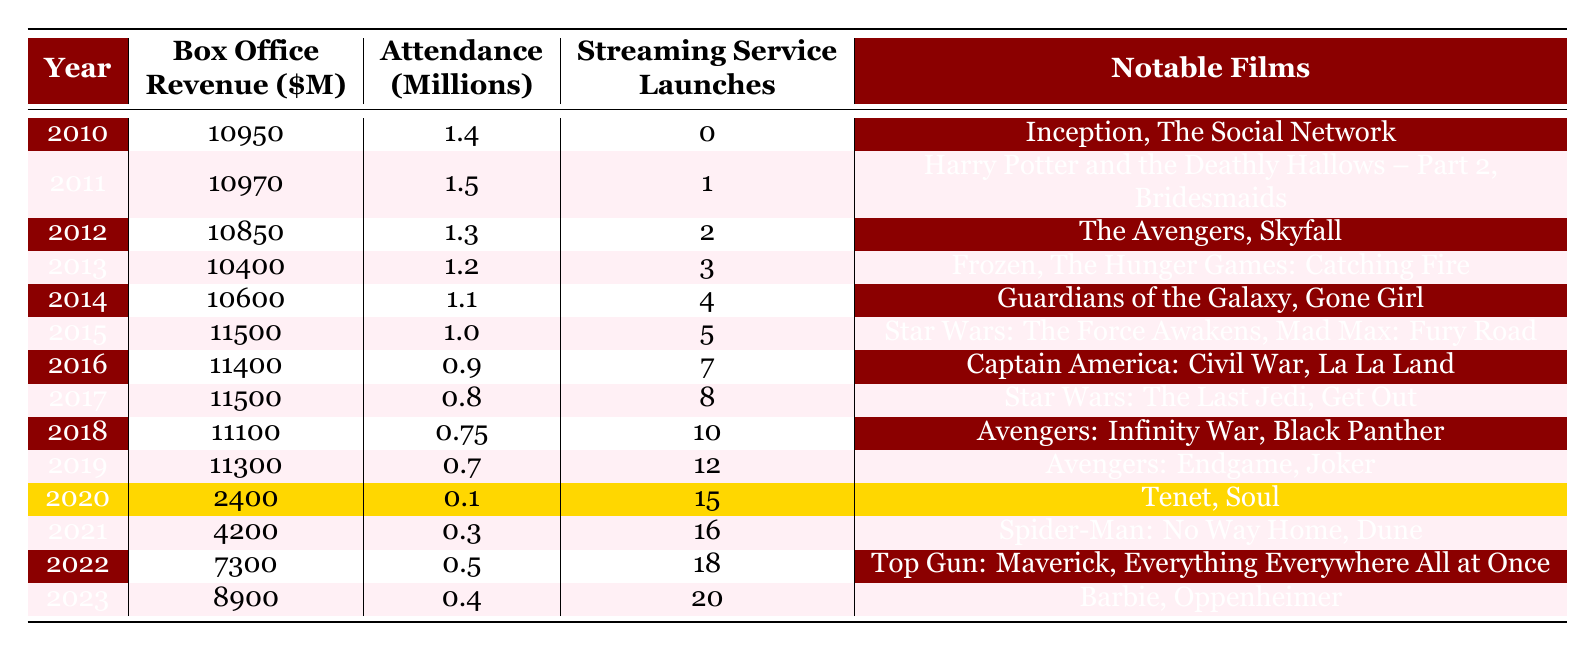What was the box office revenue in 2015? In the row for 2015, the box office revenue value is given as 11,500 million dollars.
Answer: 11500 How many streaming services launched in 2020? The table indicates that there were 15 streaming service launches in 2020.
Answer: 15 In which year did theater attendance first drop below 1 million? The attendance values show that in 2016, attendance was 0.9 million, thus it dropped below 1 million for the first time.
Answer: 2016 What was the box office revenue trend from 2010 to 2019? By comparing the box office revenues year by year from 2010 to 2019, it initially rose slightly before experiencing fluctuations, but generally maintained values around 10,000 million until 2019, where it was recorded at 11,300 million.
Answer: Fluctuating, stable around 10,000 million until 2019 What is the average attendance from 2013 to 2015? The attendance figures for 2013, 2014, and 2015 are 1.2, 1.1, and 1.0 million, respectively. Adding these gives 1.2 + 1.1 + 1.0 = 3.3 million. Dividing by 3 results in an average of 1.1 million.
Answer: 1.1 In what year were the most notable films within a single year launched? The year with the highest number of notable films listed is 2017, featuring "Star Wars: The Last Jedi" and "Get Out," totaling two notable films.
Answer: 2017 Is it true that attendance was consistently decreasing from 2014 to 2023? By examining the attendance figures year by year from 2014 to 2023, attendance decreased from 1.1 million in 2014 to 0.4 million in 2023, confirming this trend.
Answer: Yes What was the change in box office revenue from 2019 to 2021? The box office revenue in 2019 was 11,300 million and in 2021 it was 4,200 million. The difference is 11,300 - 4,200 = 7,100 million, showing a significant decline.
Answer: 7100 million decrease How many streaming services launched from 2010 to 2015? Adding the annual streaming service launches from 2010 (0) to 2015 (5) gives a total of 0 + 1 + 2 + 3 + 4 + 5 = 15 launches.
Answer: 15 Which year had the lowest theater attendance? The table shows that 2020 had the lowest attendance with only 0.1 million recorded.
Answer: 2020 What was the percentage decrease in attendance from 2019 to 2023? Attendance in 2019 was 0.7 million and in 2023 it was 0.4 million. The decrease is 0.7 - 0.4 = 0.3 million. To find the percentage decrease: (0.3 / 0.7) * 100 = ~42.86%.
Answer: ~42.86% 